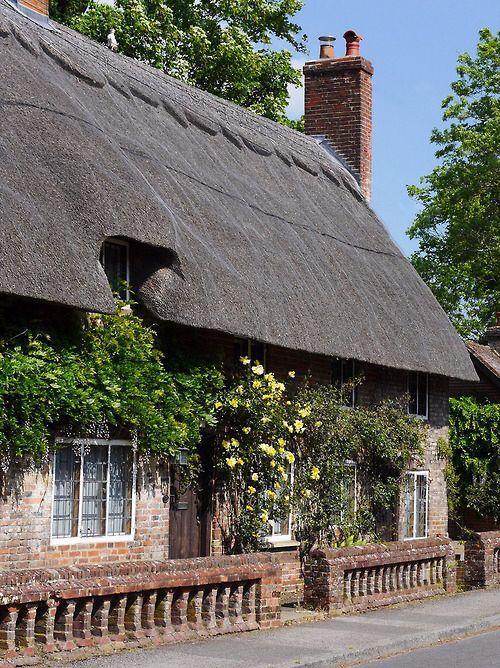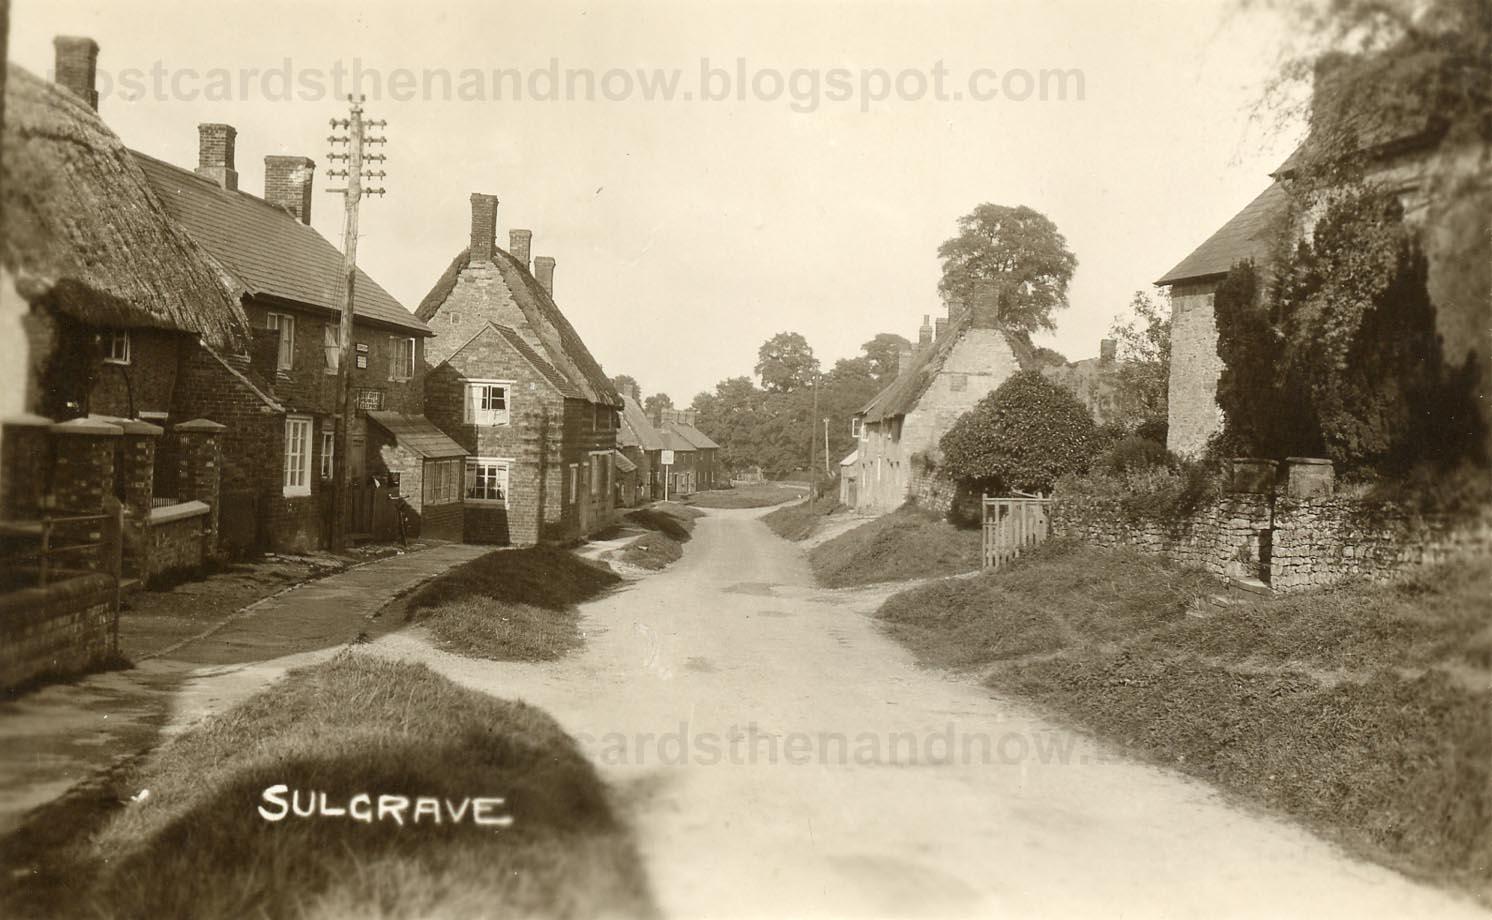The first image is the image on the left, the second image is the image on the right. For the images displayed, is the sentence "A house with a landscaped lawn has a roof with at least three notches around windows on its front side facing the street." factually correct? Answer yes or no. No. The first image is the image on the left, the second image is the image on the right. For the images displayed, is the sentence "In at least one image there is a yellow bricked house facing forward right with two chimney." factually correct? Answer yes or no. No. 